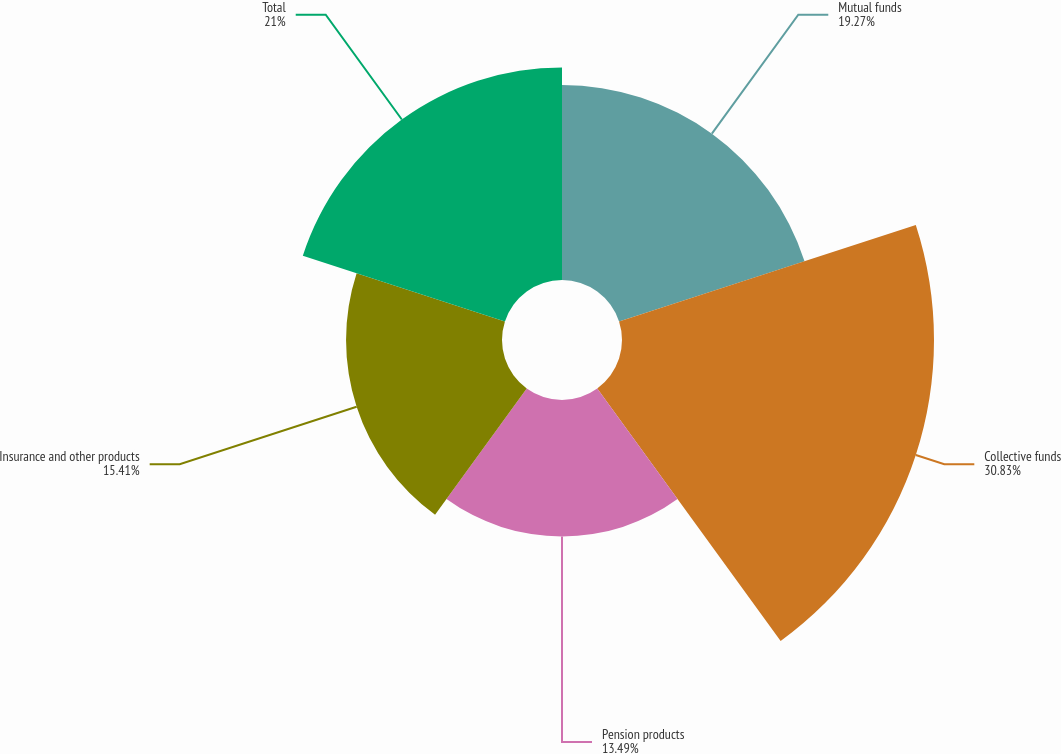<chart> <loc_0><loc_0><loc_500><loc_500><pie_chart><fcel>Mutual funds<fcel>Collective funds<fcel>Pension products<fcel>Insurance and other products<fcel>Total<nl><fcel>19.27%<fcel>30.83%<fcel>13.49%<fcel>15.41%<fcel>21.0%<nl></chart> 